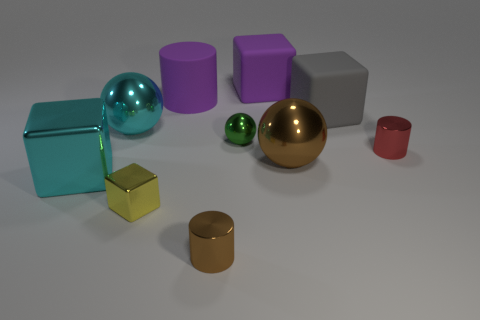How many gray things are to the right of the brown thing that is in front of the small metal cube? 1 